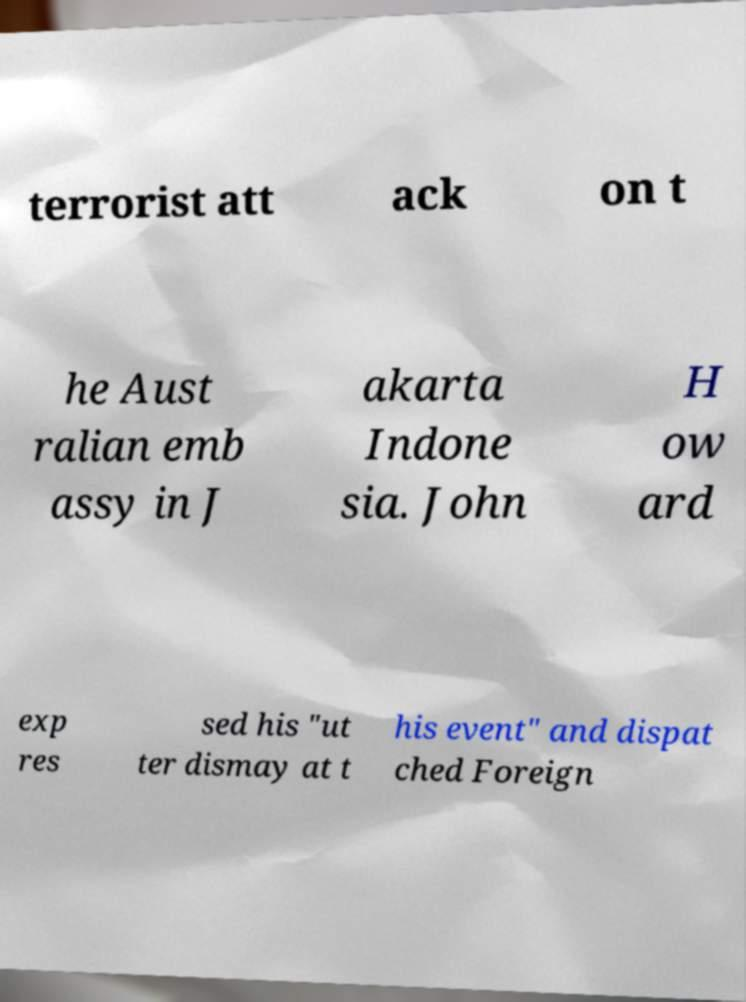There's text embedded in this image that I need extracted. Can you transcribe it verbatim? terrorist att ack on t he Aust ralian emb assy in J akarta Indone sia. John H ow ard exp res sed his "ut ter dismay at t his event" and dispat ched Foreign 